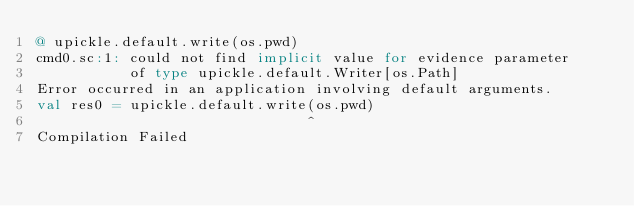Convert code to text. <code><loc_0><loc_0><loc_500><loc_500><_Scala_>@ upickle.default.write(os.pwd)
cmd0.sc:1: could not find implicit value for evidence parameter
           of type upickle.default.Writer[os.Path]
Error occurred in an application involving default arguments.
val res0 = upickle.default.write(os.pwd)
                                ^
Compilation Failed
</code> 